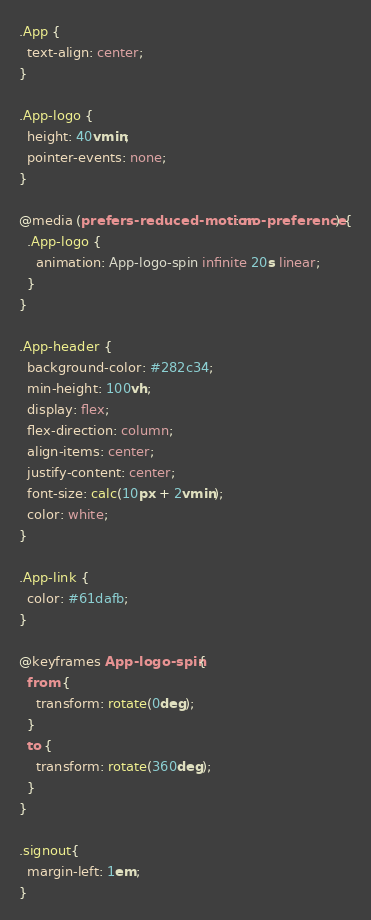Convert code to text. <code><loc_0><loc_0><loc_500><loc_500><_CSS_>.App {
  text-align: center;
}

.App-logo {
  height: 40vmin;
  pointer-events: none;
}

@media (prefers-reduced-motion: no-preference) {
  .App-logo {
    animation: App-logo-spin infinite 20s linear;
  }
}

.App-header {
  background-color: #282c34;
  min-height: 100vh;
  display: flex;
  flex-direction: column;
  align-items: center;
  justify-content: center;
  font-size: calc(10px + 2vmin);
  color: white;
}

.App-link {
  color: #61dafb;
}

@keyframes App-logo-spin {
  from {
    transform: rotate(0deg);
  }
  to {
    transform: rotate(360deg);
  }
}

.signout{
  margin-left: 1em;
}
</code> 